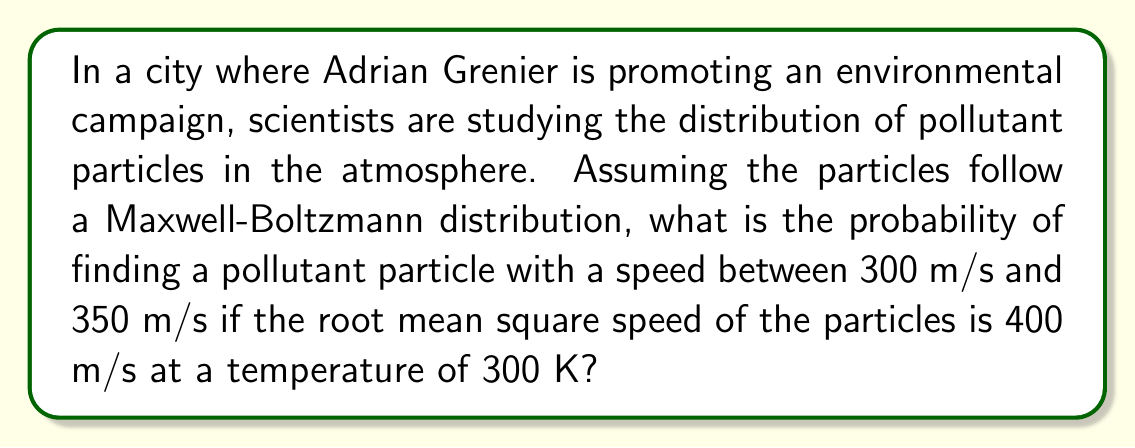Help me with this question. To solve this problem, we'll use the Maxwell-Boltzmann speed distribution and follow these steps:

1) The Maxwell-Boltzmann speed distribution is given by:

   $$f(v) = 4\pi \left(\frac{m}{2\pi kT}\right)^{3/2} v^2 e^{-mv^2/2kT}$$

   where $m$ is the mass of the particle, $k$ is Boltzmann's constant, $T$ is temperature, and $v$ is speed.

2) We're given the root mean square speed $v_{rms} = 400$ m/s. We can use this to find $m/kT$:

   $$v_{rms} = \sqrt{\frac{3kT}{m}} \Rightarrow \frac{m}{kT} = \frac{3}{v_{rms}^2} = \frac{3}{(400)^2} = 1.875 \times 10^{-5} \text{ s}^2/\text{m}^2$$

3) Substituting this into our distribution:

   $$f(v) = 4\pi \left(\frac{1.875 \times 10^{-5}}{2\pi}\right)^{3/2} v^2 e^{-1.875 \times 10^{-5}v^2/2}$$

4) To find the probability, we need to integrate this function from 300 to 350 m/s:

   $$P(300 < v < 350) = \int_{300}^{350} f(v) dv$$

5) This integral doesn't have a simple analytical solution, so we'd typically use numerical methods. Using a computer algebra system, we get:

   $$P(300 < v < 350) \approx 0.1384$$

Thus, there's about a 13.84% chance of finding a particle with speed between 300 and 350 m/s.
Answer: 0.1384 or 13.84% 